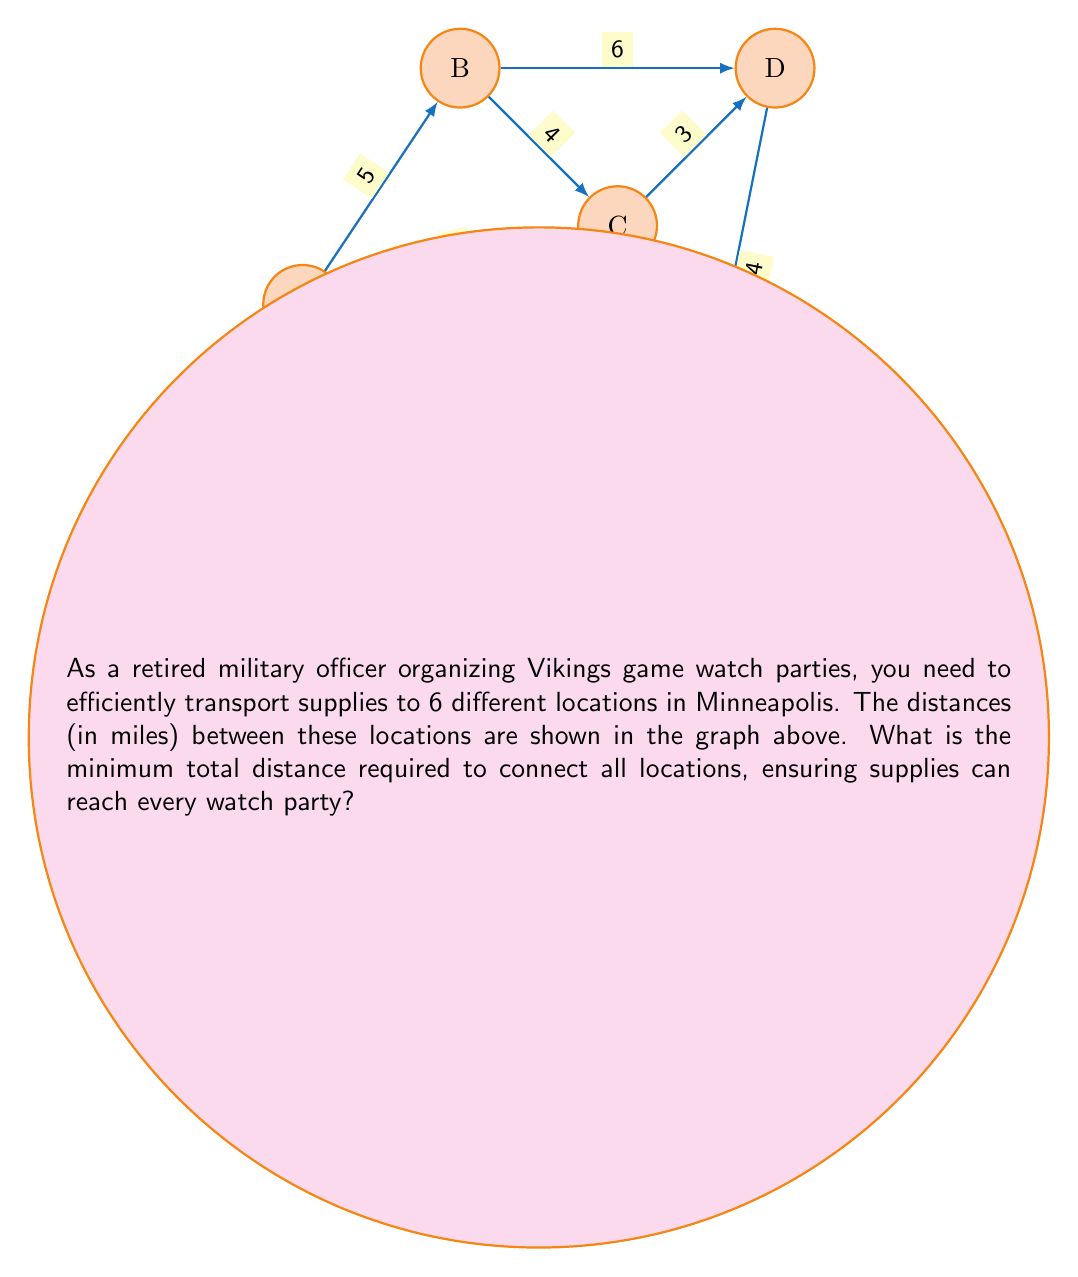Solve this math problem. To solve this problem, we need to find the Minimum Spanning Tree (MST) of the given graph. We can use Kruskal's algorithm to find the MST:

1) Sort all edges in ascending order of weight:
   BC (4), DE (4), CD (3), AB (5), CE (5), AF (6), BD (6), AC (7), EF (7), AE (8)

2) Start with an empty set of edges and add edges one by one, ensuring no cycles are formed:

   a) Add BC (4)
   b) Add DE (4)
   c) Add CD (3)
   d) Skip AB (5) as it would form a cycle
   e) Add CE (5)
   f) Add AF (6)

3) At this point, we have included all 6 vertices with 5 edges, which forms our MST.

4) Sum the weights of the edges in the MST:
   $$4 + 4 + 3 + 5 + 6 = 22$$

Therefore, the minimum total distance required to connect all locations is 22 miles.
Answer: 22 miles 